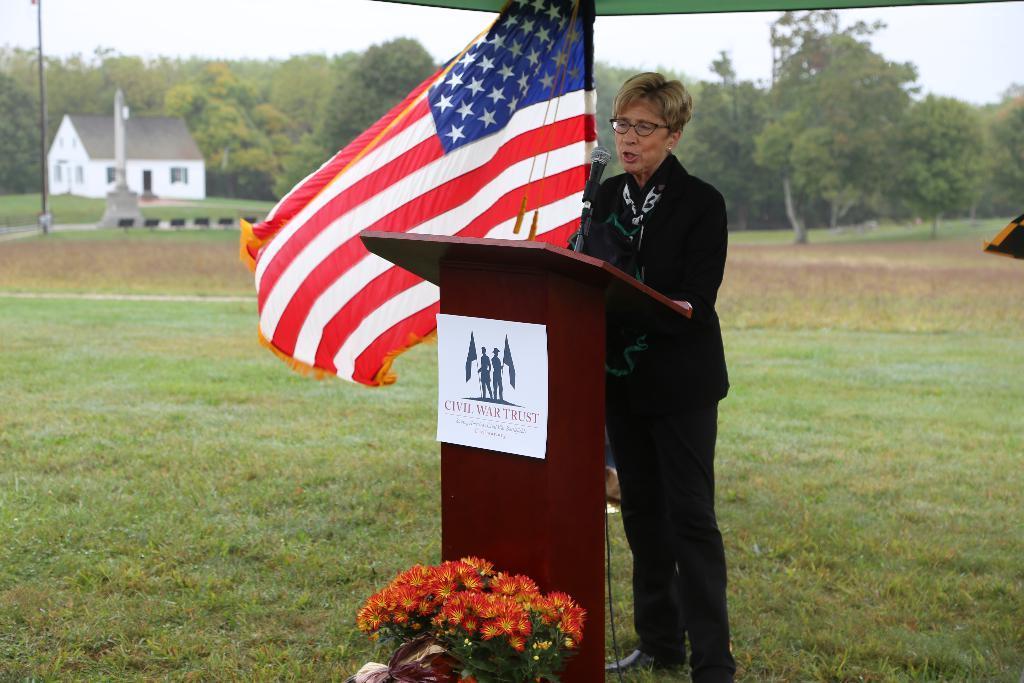Could you give a brief overview of what you see in this image? In this picture I can see a woman standing and talking in front of the mike, we can see some flowers in front of the podium, side we can see a flag, behind we can see a house, tent, plants, trees and grass. 